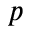Convert formula to latex. <formula><loc_0><loc_0><loc_500><loc_500>p</formula> 